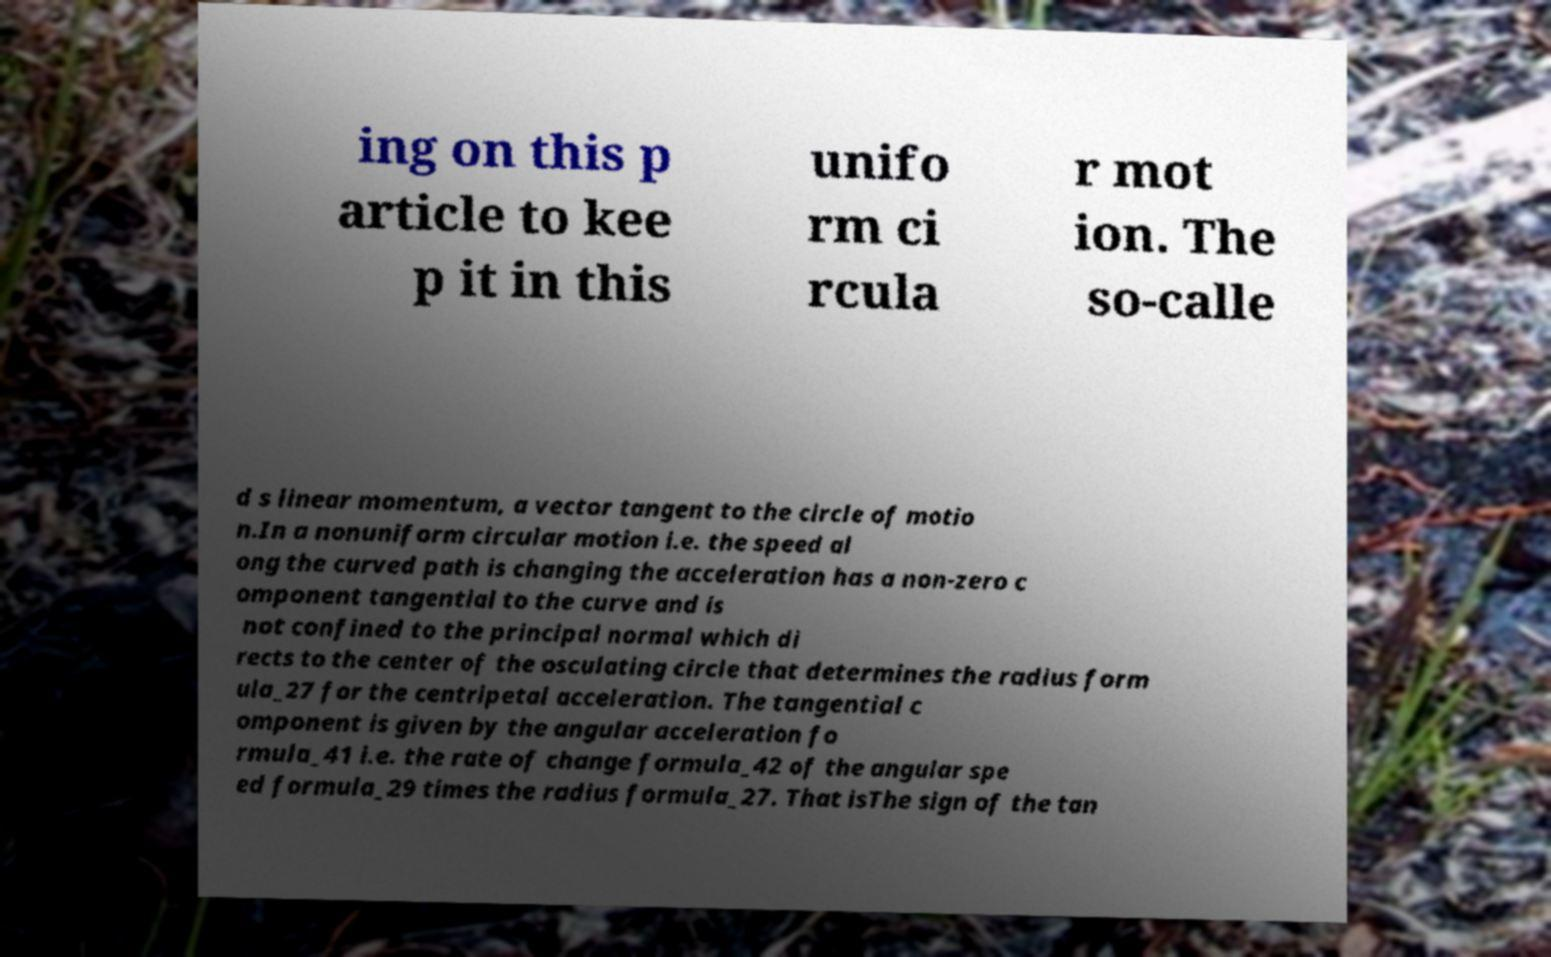Please identify and transcribe the text found in this image. ing on this p article to kee p it in this unifo rm ci rcula r mot ion. The so-calle d s linear momentum, a vector tangent to the circle of motio n.In a nonuniform circular motion i.e. the speed al ong the curved path is changing the acceleration has a non-zero c omponent tangential to the curve and is not confined to the principal normal which di rects to the center of the osculating circle that determines the radius form ula_27 for the centripetal acceleration. The tangential c omponent is given by the angular acceleration fo rmula_41 i.e. the rate of change formula_42 of the angular spe ed formula_29 times the radius formula_27. That isThe sign of the tan 